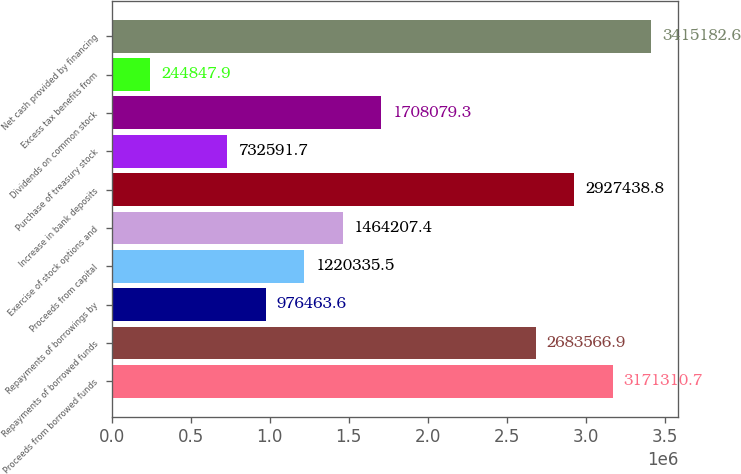Convert chart to OTSL. <chart><loc_0><loc_0><loc_500><loc_500><bar_chart><fcel>Proceeds from borrowed funds<fcel>Repayments of borrowed funds<fcel>Repayments of borrowings by<fcel>Proceeds from capital<fcel>Exercise of stock options and<fcel>Increase in bank deposits<fcel>Purchase of treasury stock<fcel>Dividends on common stock<fcel>Excess tax benefits from<fcel>Net cash provided by financing<nl><fcel>3.17131e+06<fcel>2.68357e+06<fcel>976464<fcel>1.22034e+06<fcel>1.46421e+06<fcel>2.92744e+06<fcel>732592<fcel>1.70808e+06<fcel>244848<fcel>3.41518e+06<nl></chart> 